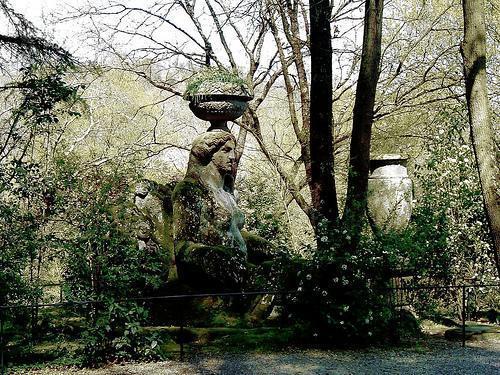How many pieces is the center tree trunk split into?
Give a very brief answer. 2. How many urns are there?
Give a very brief answer. 2. How many eyes are on the statue?
Give a very brief answer. 1. How many tree trunks are near the flowers?
Give a very brief answer. 2. 